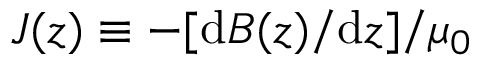<formula> <loc_0><loc_0><loc_500><loc_500>J ( z ) \equiv - [ d B ( z ) / d z ] / \mu _ { 0 }</formula> 